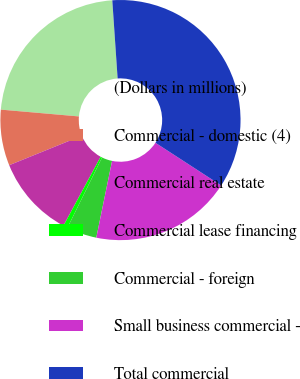Convert chart to OTSL. <chart><loc_0><loc_0><loc_500><loc_500><pie_chart><fcel>(Dollars in millions)<fcel>Commercial - domestic (4)<fcel>Commercial real estate<fcel>Commercial lease financing<fcel>Commercial - foreign<fcel>Small business commercial -<fcel>Total commercial<nl><fcel>22.53%<fcel>7.52%<fcel>10.99%<fcel>0.59%<fcel>4.06%<fcel>19.06%<fcel>35.25%<nl></chart> 